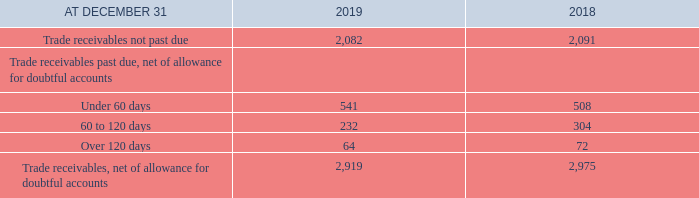CREDIT RISK
In many instances, trade receivables are written off directly to bad debt expense if the account has not been collected after a predetermined period of time.
The following table provides further details on trade receivables, net of allowance for doubtful accounts.
When are trade receivables written off directly to bad debt expense? If the account has not been collected after a predetermined period of time. What is the amount of trade receivables not past due in 2019? 2,082. What segments does the trade receivables past due, net of allowance for doubtful accounts consist of? Under 60 days, 60 to 120 days, over 120 days. What is the total Trade receivables past due, net of allowance for doubtful accounts for 2019? 541+232+64
Answer: 837. What is the change in trade receivables not past due in 2019? 2,082-2,091
Answer: -9. What is the percentage of trade receivables past due, net of allowance for doubtful accounts out of the total trade receivables, net of allowance for doubtful accounts in 2019?
Answer scale should be: percent. (541+232+64)/2,919
Answer: 28.67. 